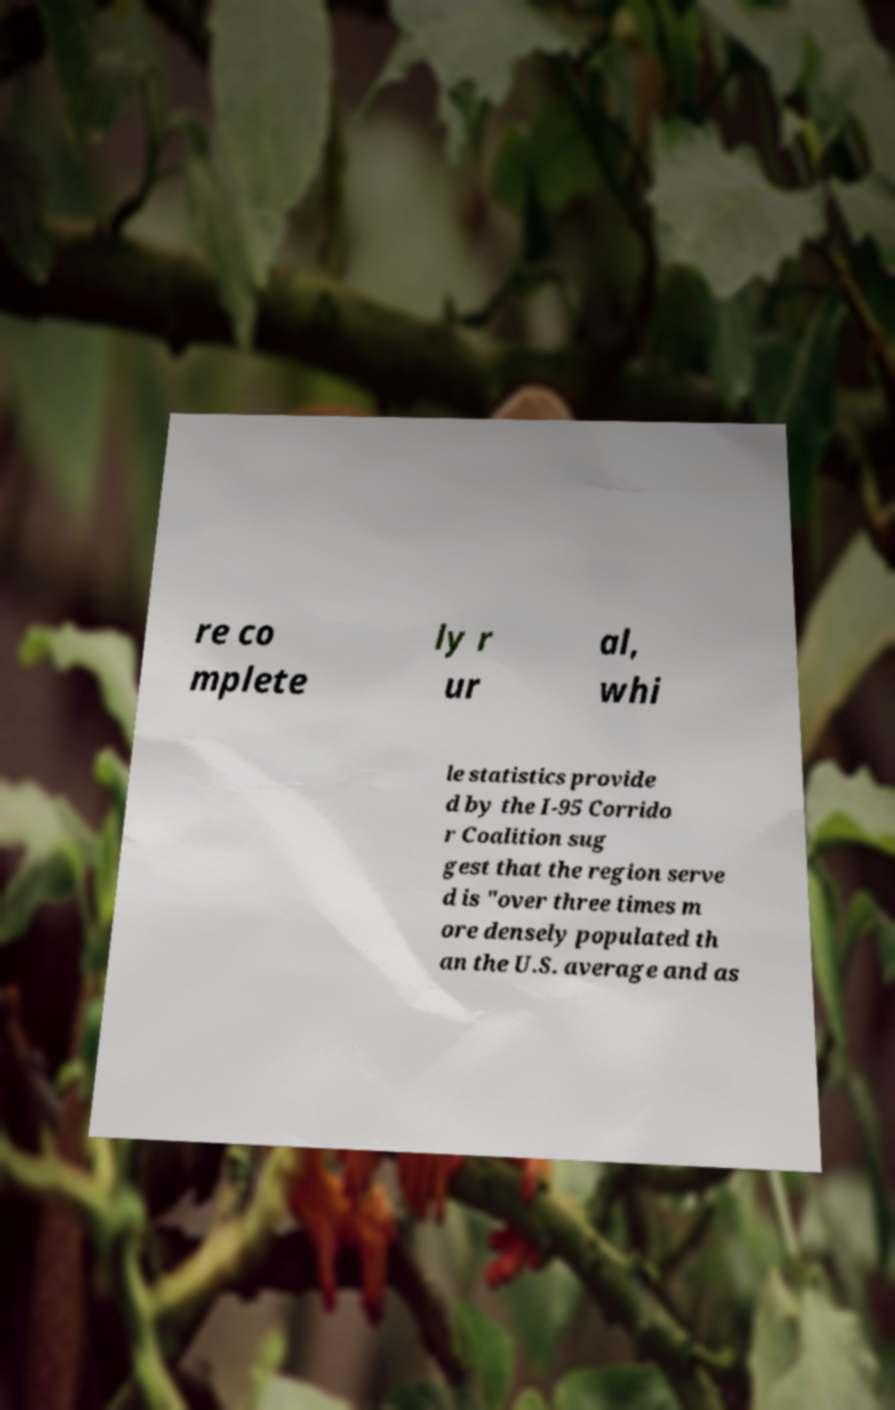Please identify and transcribe the text found in this image. re co mplete ly r ur al, whi le statistics provide d by the I-95 Corrido r Coalition sug gest that the region serve d is "over three times m ore densely populated th an the U.S. average and as 